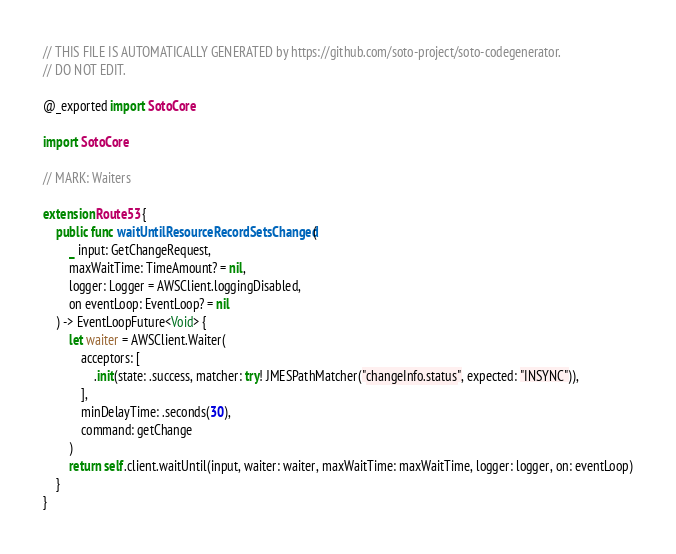<code> <loc_0><loc_0><loc_500><loc_500><_Swift_>
// THIS FILE IS AUTOMATICALLY GENERATED by https://github.com/soto-project/soto-codegenerator.
// DO NOT EDIT.

@_exported import SotoCore

import SotoCore

// MARK: Waiters

extension Route53 {
    public func waitUntilResourceRecordSetsChanged(
        _ input: GetChangeRequest,
        maxWaitTime: TimeAmount? = nil,
        logger: Logger = AWSClient.loggingDisabled,
        on eventLoop: EventLoop? = nil
    ) -> EventLoopFuture<Void> {
        let waiter = AWSClient.Waiter(
            acceptors: [
                .init(state: .success, matcher: try! JMESPathMatcher("changeInfo.status", expected: "INSYNC")),
            ],
            minDelayTime: .seconds(30),
            command: getChange
        )
        return self.client.waitUntil(input, waiter: waiter, maxWaitTime: maxWaitTime, logger: logger, on: eventLoop)
    }
}
</code> 